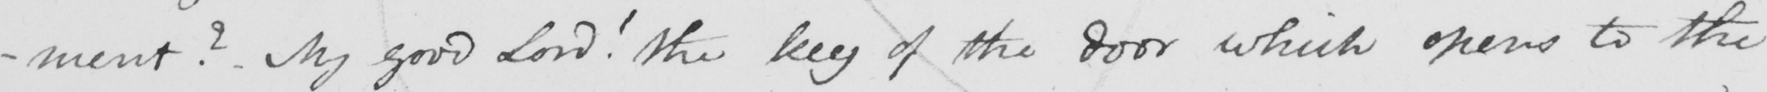What does this handwritten line say? -ment ?  My good Lord !  The key of the door which opens to the 